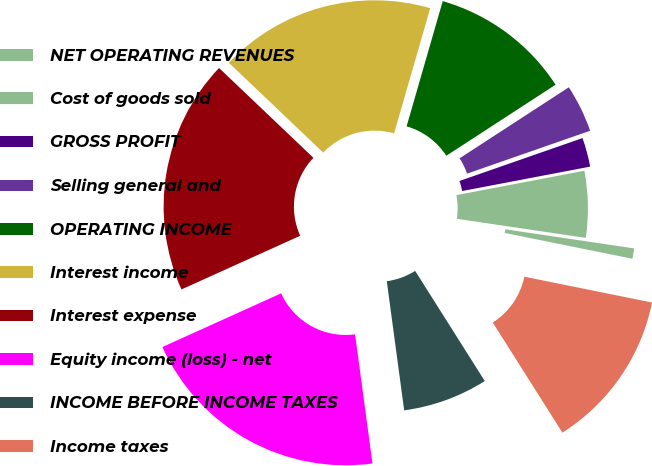Convert chart. <chart><loc_0><loc_0><loc_500><loc_500><pie_chart><fcel>NET OPERATING REVENUES<fcel>Cost of goods sold<fcel>GROSS PROFIT<fcel>Selling general and<fcel>OPERATING INCOME<fcel>Interest income<fcel>Interest expense<fcel>Equity income (loss) - net<fcel>INCOME BEFORE INCOME TAXES<fcel>Income taxes<nl><fcel>0.83%<fcel>5.34%<fcel>2.34%<fcel>3.84%<fcel>11.35%<fcel>17.36%<fcel>18.86%<fcel>20.37%<fcel>6.84%<fcel>12.85%<nl></chart> 